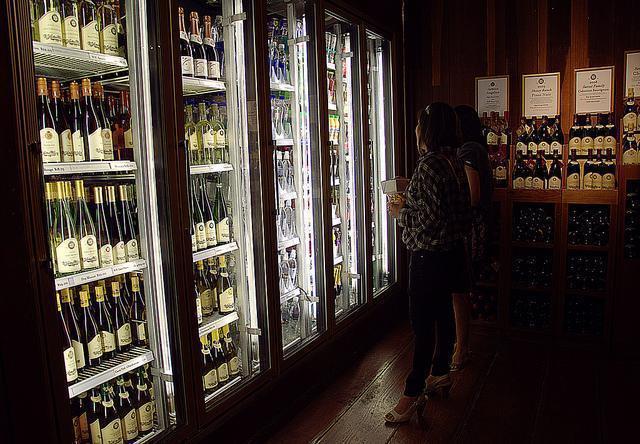Where are these two girls at?
Pick the right solution, then justify: 'Answer: answer
Rationale: rationale.'
Options: Restaurant, liquor store, convenience store, supermarket. Answer: liquor store.
Rationale: This is obvious based on all of the alcohol bottles. 